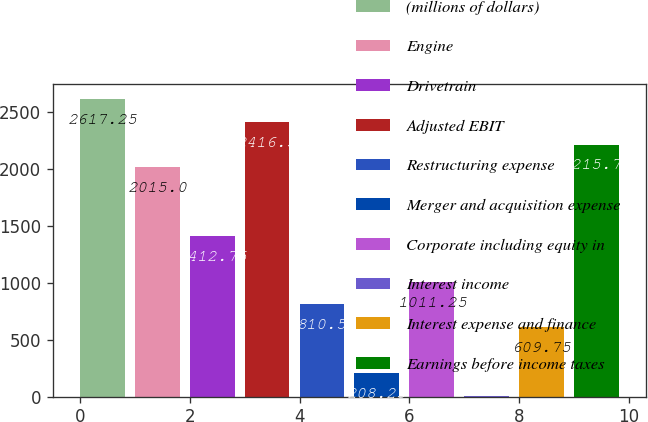<chart> <loc_0><loc_0><loc_500><loc_500><bar_chart><fcel>(millions of dollars)<fcel>Engine<fcel>Drivetrain<fcel>Adjusted EBIT<fcel>Restructuring expense<fcel>Merger and acquisition expense<fcel>Corporate including equity in<fcel>Interest income<fcel>Interest expense and finance<fcel>Earnings before income taxes<nl><fcel>2617.25<fcel>2015<fcel>1412.75<fcel>2416.5<fcel>810.5<fcel>208.25<fcel>1011.25<fcel>7.5<fcel>609.75<fcel>2215.75<nl></chart> 